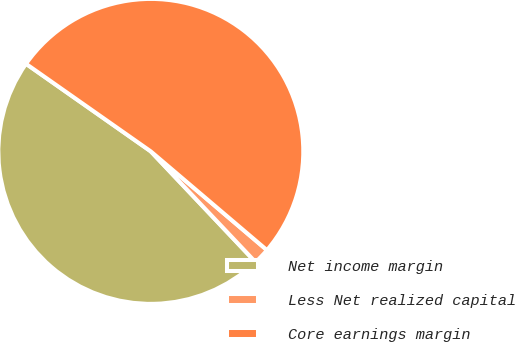<chart> <loc_0><loc_0><loc_500><loc_500><pie_chart><fcel>Net income margin<fcel>Less Net realized capital<fcel>Core earnings margin<nl><fcel>46.79%<fcel>1.73%<fcel>51.47%<nl></chart> 